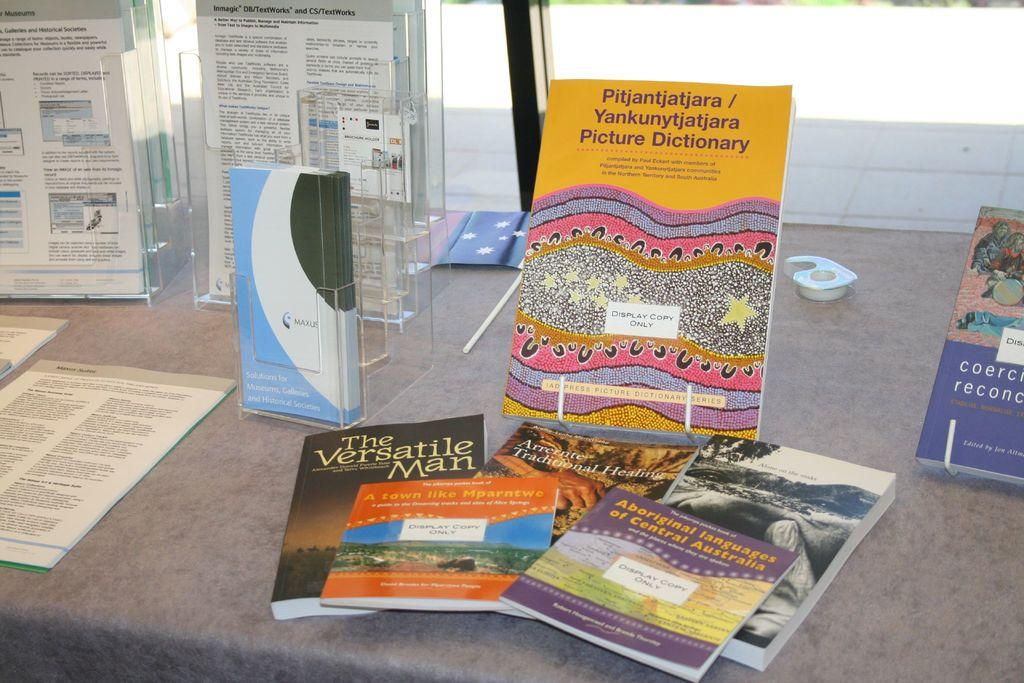Provide a one-sentence caption for the provided image. A collection of paperback books include a picture dictionary and a book about language. 